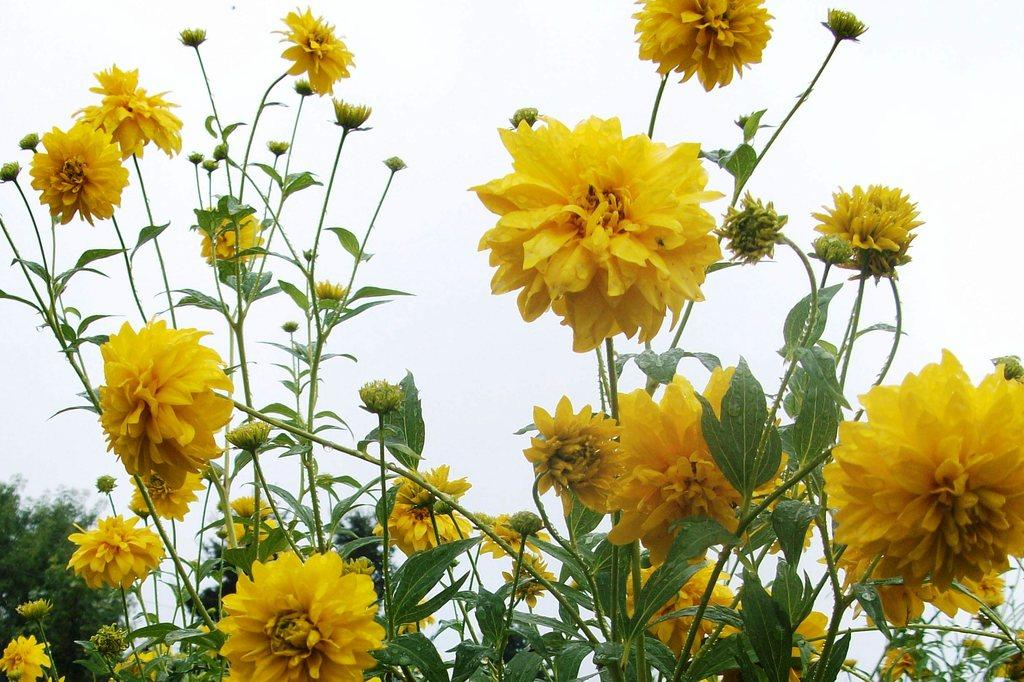What color are the flowers in the image? The flowers in the image are yellow. What color are the plants in the image? The plants in the image are green. What is the color of the sky in the image? The sky appears to be white in the image. Is there a locket with a picture of a person in the image? There is no mention of a locket or a person's picture in the provided facts, so we cannot confirm its presence in the image. 